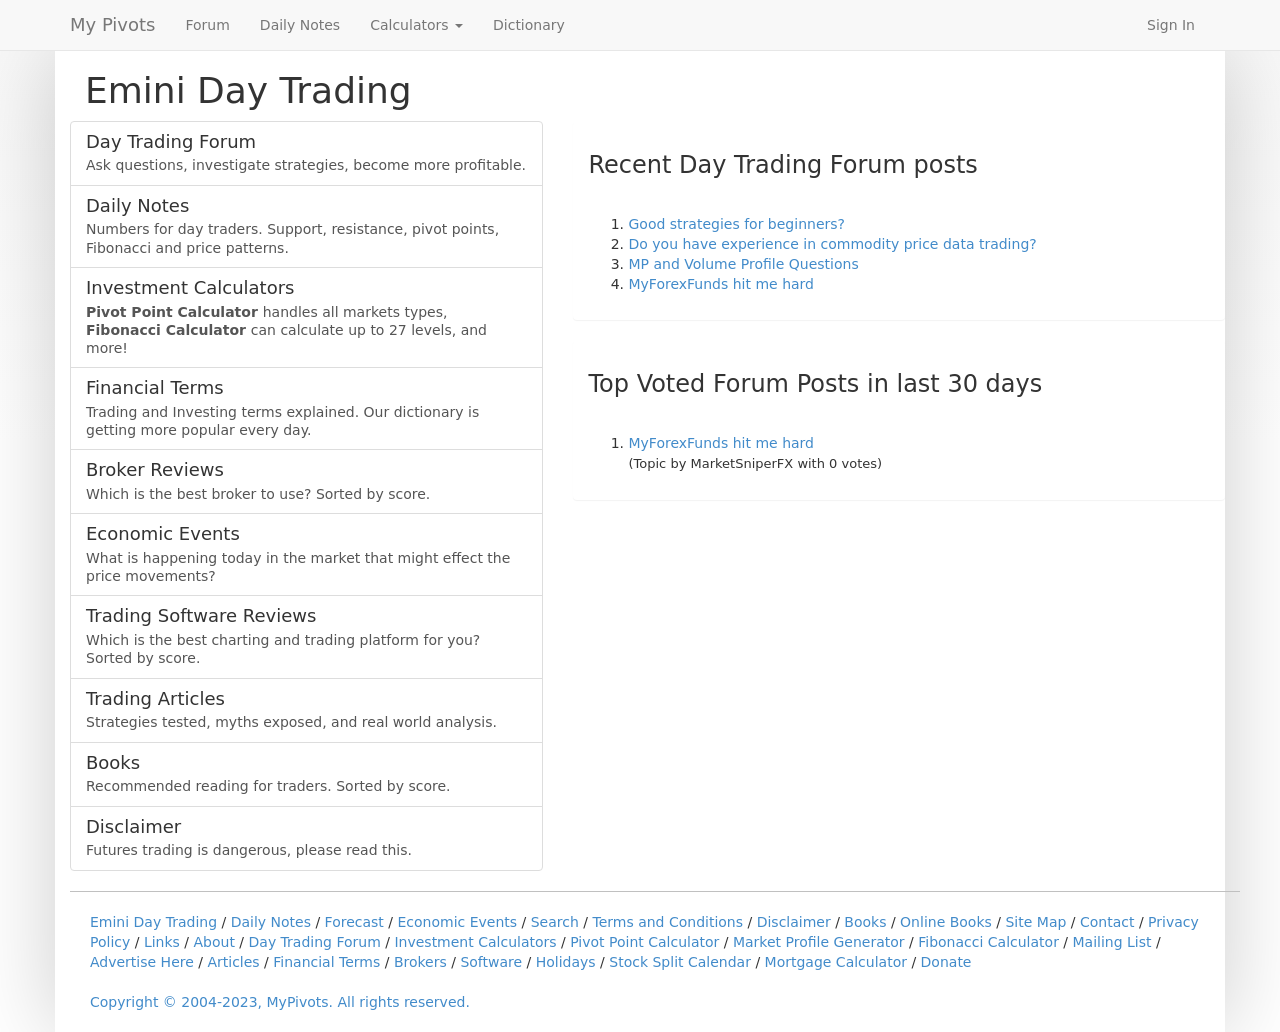How could the visual design of the 'Recent Day Trading Forum posts' section be improved? To improve visual design, consider using a card layout for each post with a subtle hover effect to make them more eye-catching. Including thumbnail images or icons next to each post could also help visually categorize them, enhancing the overall user experience.  What are some accessibility features that can be added to the site in the image? To improve accessibility, ensure all images have descriptive alt text, use a color scheme with sufficient contrast, provide keyboard navigable interfaces, and include screen reader support. ARIA roles and properties can be utilized to inform users of dynamic content changes within the site. 